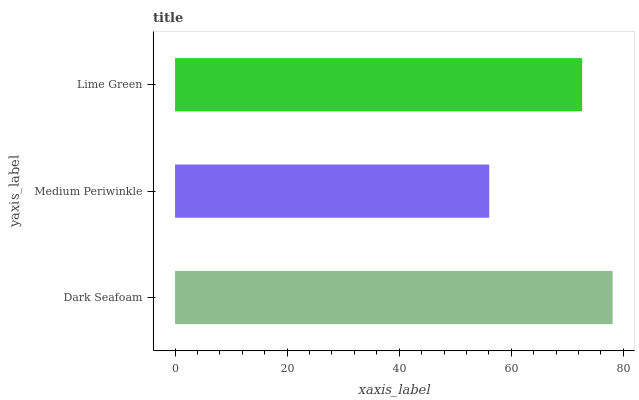Is Medium Periwinkle the minimum?
Answer yes or no. Yes. Is Dark Seafoam the maximum?
Answer yes or no. Yes. Is Lime Green the minimum?
Answer yes or no. No. Is Lime Green the maximum?
Answer yes or no. No. Is Lime Green greater than Medium Periwinkle?
Answer yes or no. Yes. Is Medium Periwinkle less than Lime Green?
Answer yes or no. Yes. Is Medium Periwinkle greater than Lime Green?
Answer yes or no. No. Is Lime Green less than Medium Periwinkle?
Answer yes or no. No. Is Lime Green the high median?
Answer yes or no. Yes. Is Lime Green the low median?
Answer yes or no. Yes. Is Medium Periwinkle the high median?
Answer yes or no. No. Is Medium Periwinkle the low median?
Answer yes or no. No. 